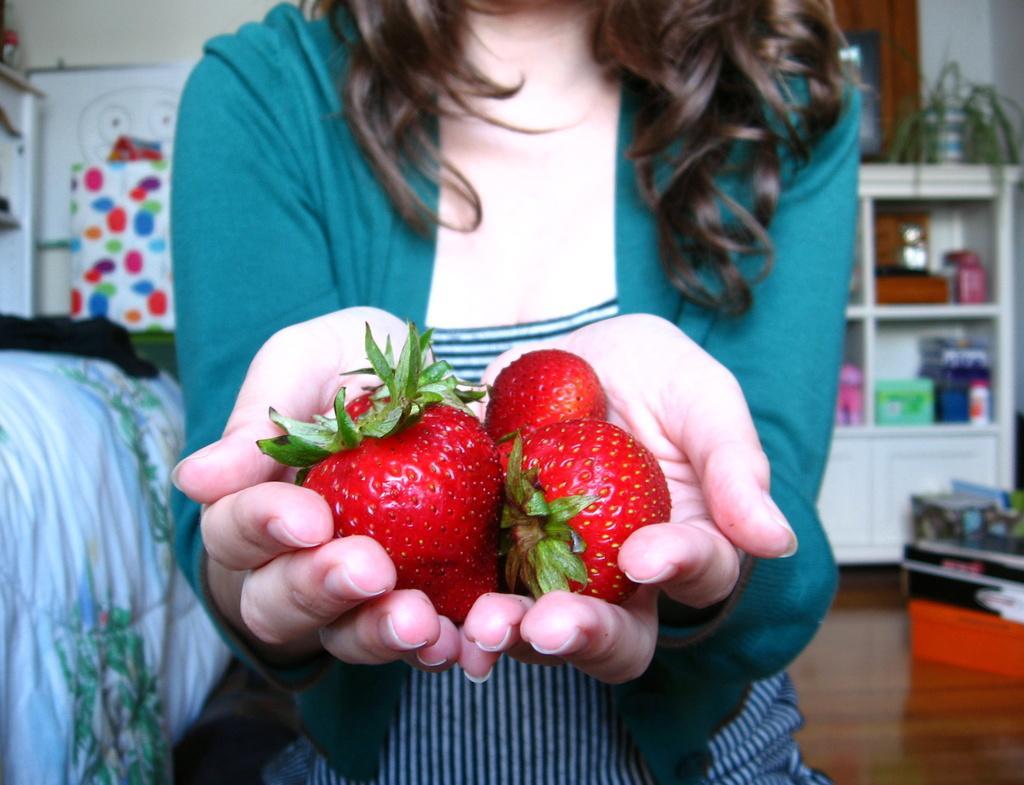How would you summarize this image in a sentence or two? In this image a woman is holding some fruits in her hand. Left side there is a bed. Right side there are few objects on the floor. Behind there is a wooden furniture having few objects in it. On it there is a pot having a plant. Left side there is a board having some drawings. Before it there is some object. Background there is a wall. 